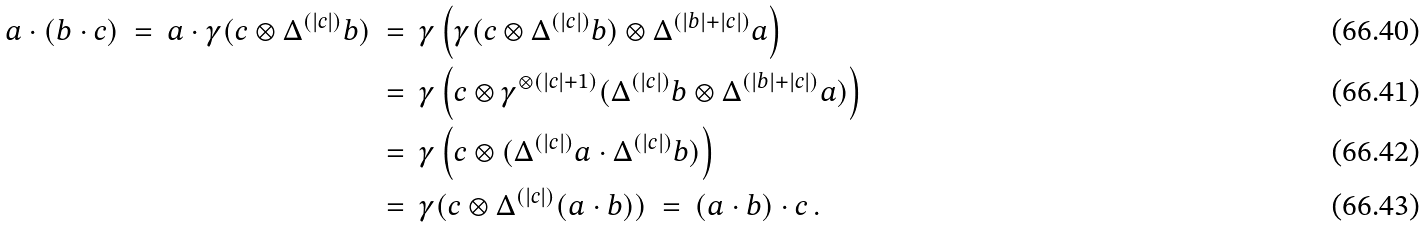Convert formula to latex. <formula><loc_0><loc_0><loc_500><loc_500>a \cdot ( b \cdot c ) \ = \ a \cdot \gamma ( c \otimes \Delta ^ { ( | c | ) } b ) \ & = \ \gamma \left ( \gamma ( c \otimes \Delta ^ { ( | c | ) } b ) \otimes \Delta ^ { ( | b | + | c | ) } a \right ) \\ & = \ \gamma \left ( c \otimes \gamma ^ { \otimes ( | c | + 1 ) } ( \Delta ^ { ( | c | ) } b \otimes \Delta ^ { ( | b | + | c | ) } a ) \right ) \\ & = \ \gamma \left ( c \otimes ( \Delta ^ { ( | c | ) } a \cdot \Delta ^ { ( | c | ) } b ) \right ) \\ & = \ \gamma ( c \otimes \Delta ^ { ( | c | ) } ( a \cdot b ) ) \ = \ ( a \cdot b ) \cdot c \, .</formula> 